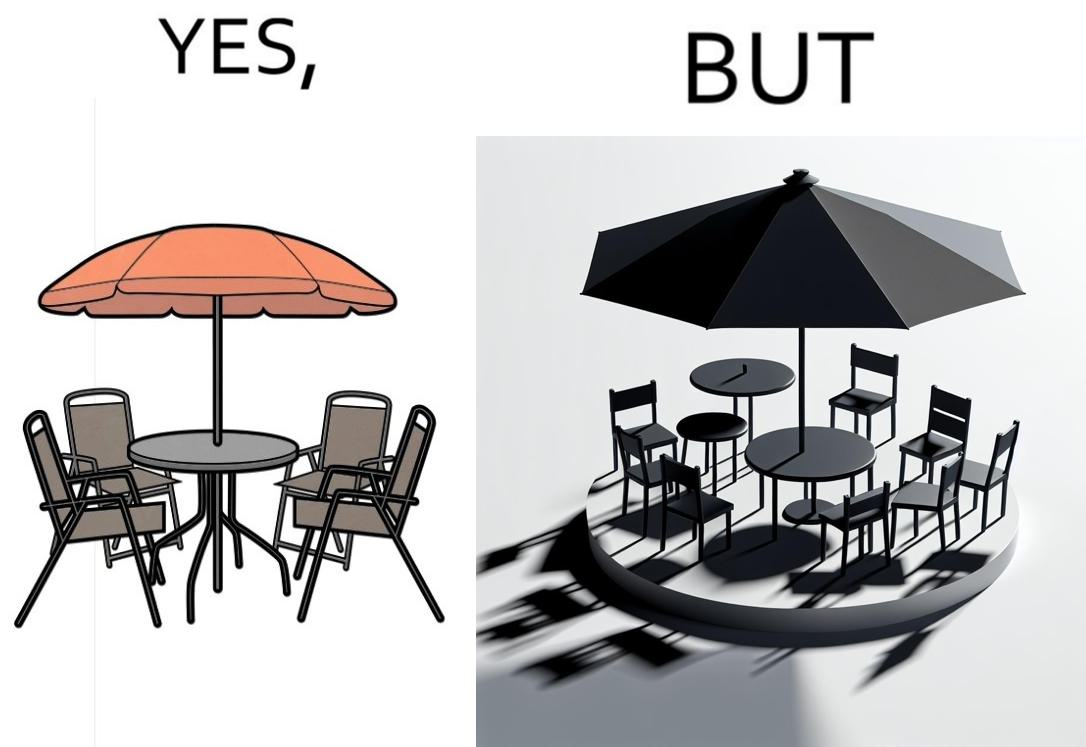What is shown in this image? The image is ironical, as the umbrella is meant to provide shadow in the area where the chairs are present, but due to the orientation of the rays of the sun, all the chairs are in sunlight, and the umbrella is of no use in this situation. 